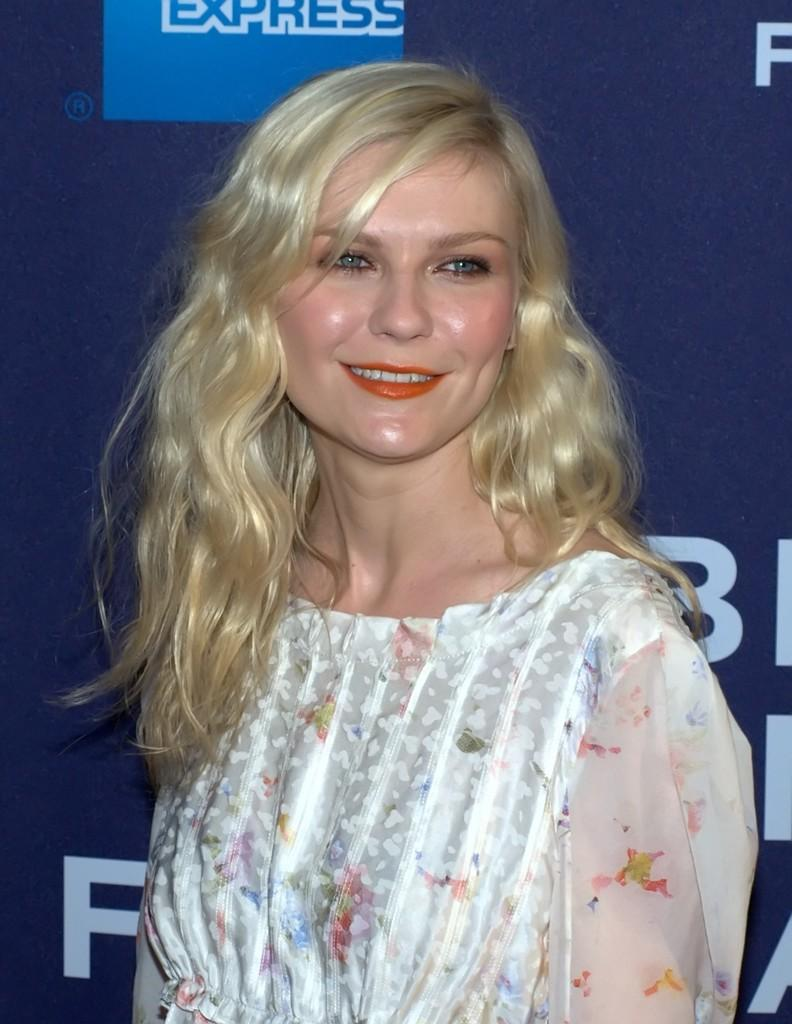What is the lady in the image doing? The lady is standing in the image and smiling. Can you describe the background of the image? There is a blue wall in the background of the image. Is there any text or image on the blue wall? Yes, there is something written on the blue wall. What type of umbrella is the lady holding in the image? There is no umbrella present in the image. How does the lumber contribute to the lady's feelings in the image? There is no mention of lumber in the image, and it cannot be determined how it would affect the lady's feelings. 